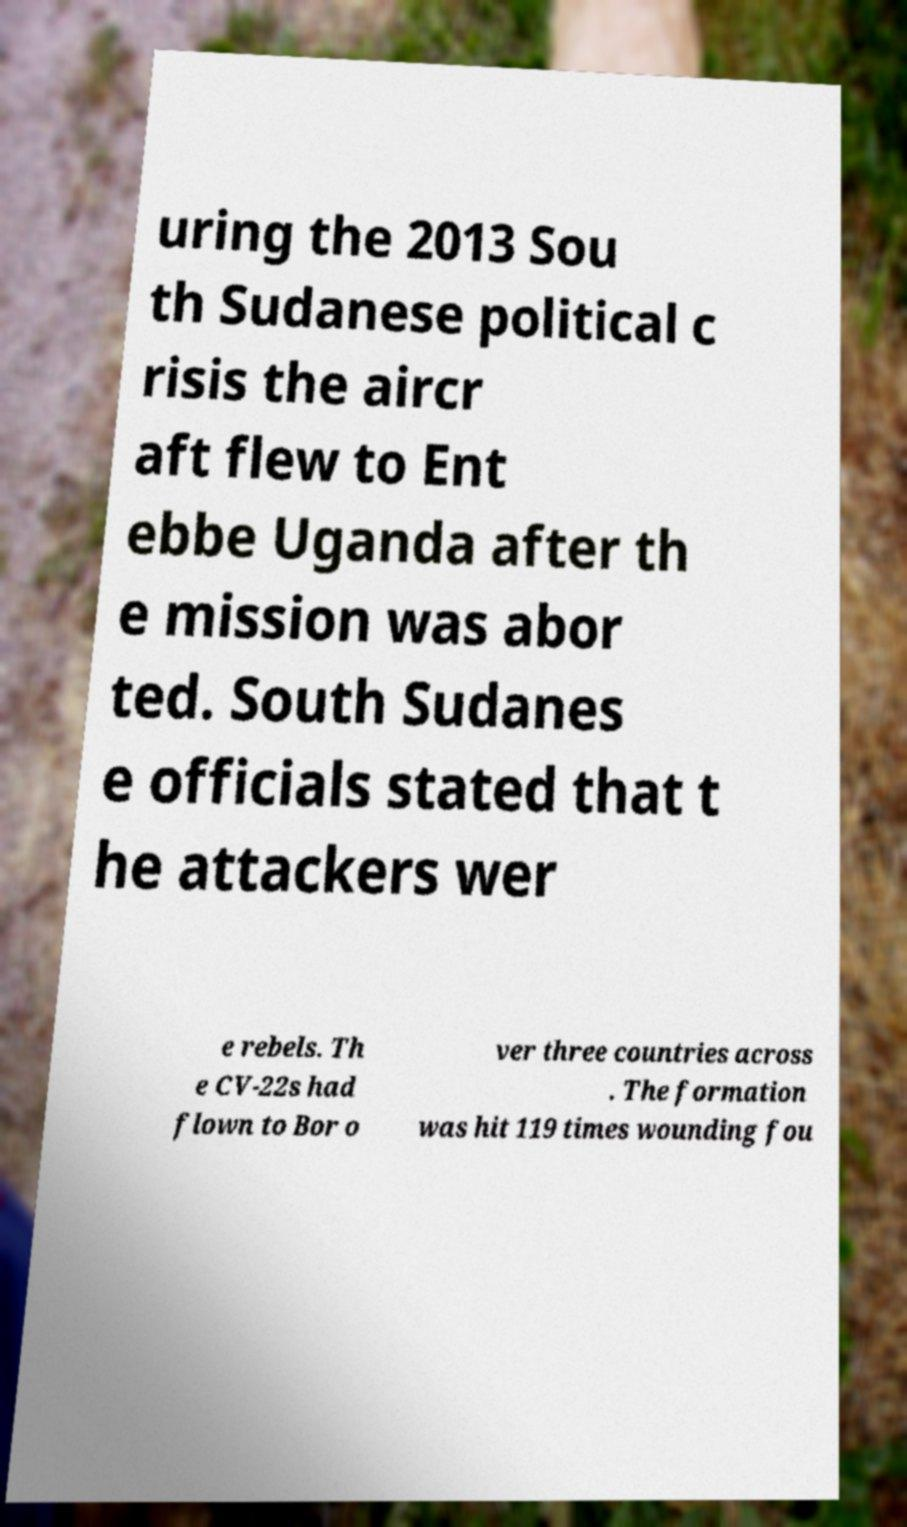Could you assist in decoding the text presented in this image and type it out clearly? uring the 2013 Sou th Sudanese political c risis the aircr aft flew to Ent ebbe Uganda after th e mission was abor ted. South Sudanes e officials stated that t he attackers wer e rebels. Th e CV-22s had flown to Bor o ver three countries across . The formation was hit 119 times wounding fou 